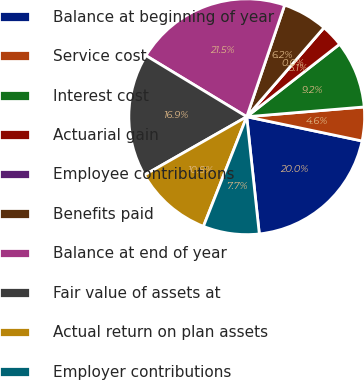<chart> <loc_0><loc_0><loc_500><loc_500><pie_chart><fcel>Balance at beginning of year<fcel>Service cost<fcel>Interest cost<fcel>Actuarial gain<fcel>Employee contributions<fcel>Benefits paid<fcel>Balance at end of year<fcel>Fair value of assets at<fcel>Actual return on plan assets<fcel>Employer contributions<nl><fcel>20.0%<fcel>4.62%<fcel>9.23%<fcel>3.08%<fcel>0.0%<fcel>6.16%<fcel>21.53%<fcel>16.92%<fcel>10.77%<fcel>7.69%<nl></chart> 